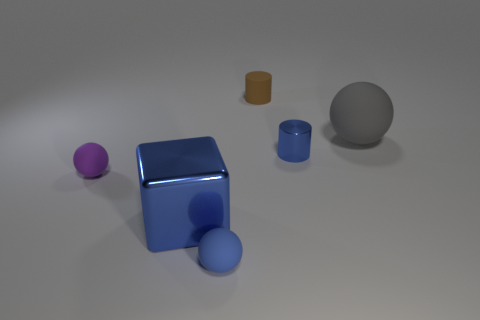How big is the rubber ball to the right of the blue thing on the right side of the blue rubber object that is on the left side of the tiny shiny cylinder? The rubber ball appears to be moderately sized in relation to the objects in the image, with a diameter that seems to be a bit larger than that of the blue cylinder nearby, but smaller than the grey sphere in the background. 